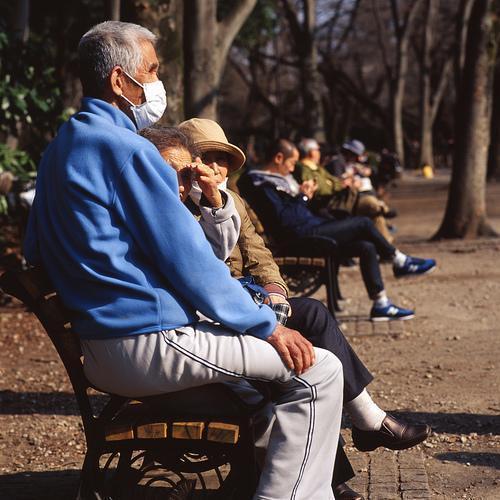How many people are on the bench?
Give a very brief answer. 3. 